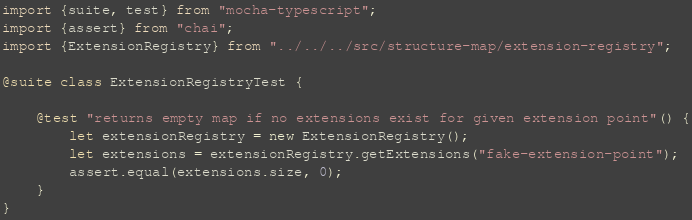<code> <loc_0><loc_0><loc_500><loc_500><_TypeScript_>import {suite, test} from "mocha-typescript";
import {assert} from "chai";
import {ExtensionRegistry} from "../../../src/structure-map/extension-registry";

@suite class ExtensionRegistryTest {

    @test "returns empty map if no extensions exist for given extension point"() {
        let extensionRegistry = new ExtensionRegistry();
        let extensions = extensionRegistry.getExtensions("fake-extension-point");
        assert.equal(extensions.size, 0);
    }
}
</code> 